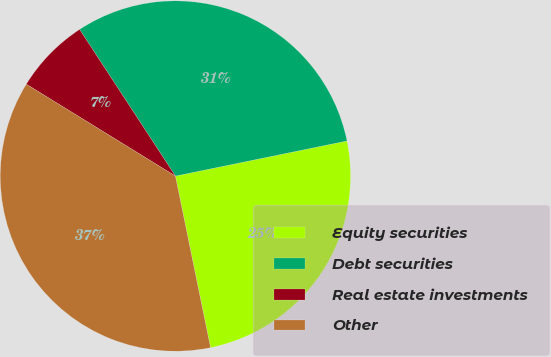Convert chart. <chart><loc_0><loc_0><loc_500><loc_500><pie_chart><fcel>Equity securities<fcel>Debt securities<fcel>Real estate investments<fcel>Other<nl><fcel>25.0%<fcel>31.0%<fcel>7.0%<fcel>37.0%<nl></chart> 